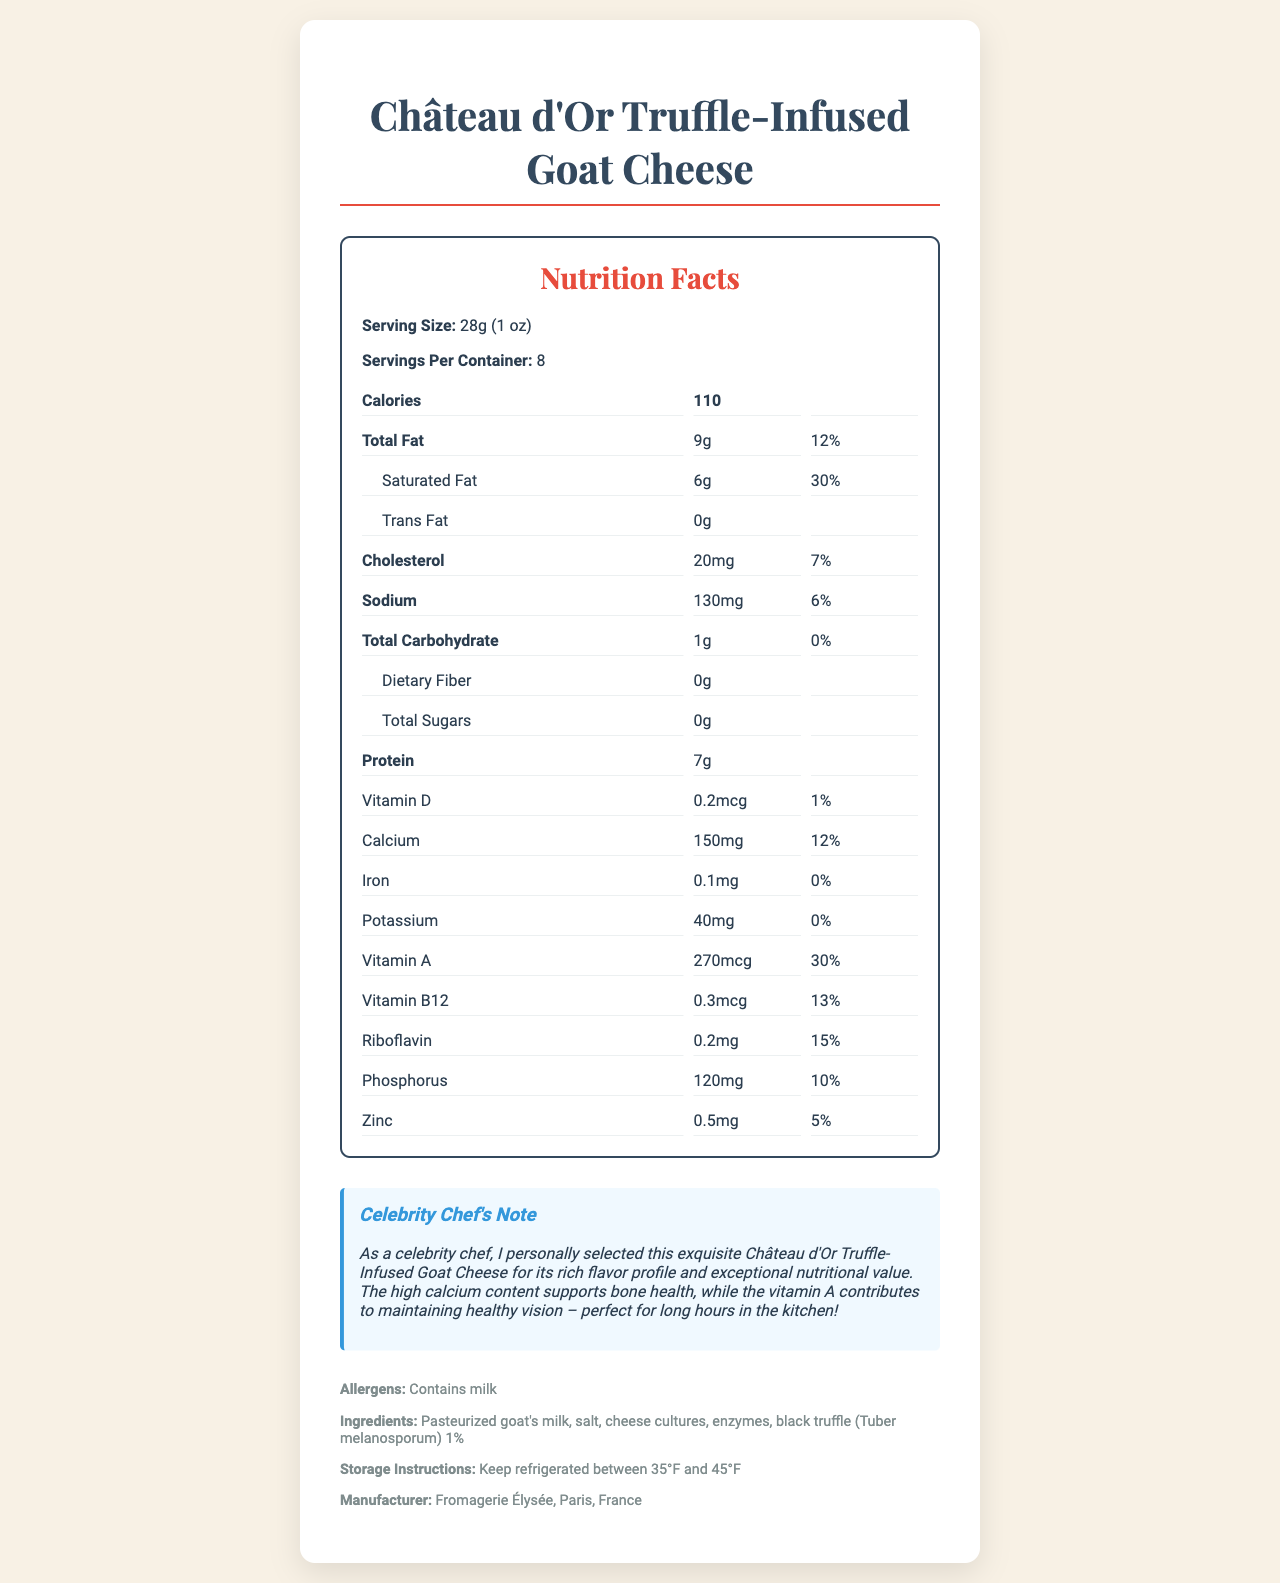how much calcium does one serving of Château d'Or Truffle-Infused Goat Cheese contain? The nutrition facts clearly state that each serving of 28g contains 150 mg of calcium.
Answer: 150 mg what percentage of the daily value for calcium does one serving provide? The document specifies that one serving provides 12% of the daily value for calcium.
Answer: 12% what vitamin has the highest daily value percentage in the cheese? The document lists Vitamin A with a daily value of 30%, which is the highest among the vitamins mentioned.
Answer: Vitamin A how much vitamin D is in one serving of the cheese? According to the nutrition facts, one serving contains 0.2 mcg of vitamin D.
Answer: 0.2 mcg how many grams of protein are in a serving? The document mentions that there are 7 grams of protein in each serving.
Answer: 7 g which vitamin contributes to healthy vision, according to the celebrity chef's note? The celebrity chef's note specifically mentions that vitamin A contributes to maintaining healthy vision.
Answer: Vitamin A how much phosphorus does the cheese contain per serving? The nutrition facts section lists phosphorus content as 120 mg per serving.
Answer: 120 mg what is the serving size of the Château d'Or Truffle-Infused Goat Cheese? The document defines the serving size as 28 grams, which is equivalent to 1 ounce.
Answer: 28g (1 oz) does the product contain any dietary fiber? The nutrition facts indicate that the cheese contains 0g of dietary fiber.
Answer: No what should be the storage temperature for this cheese? A. Below 35°F B. Between 35°F and 45°F C. Above 45°F The storage instructions clearly state that the cheese should be kept refrigerated between 35°F and 45°F.
Answer: B. Between 35°F and 45°F which of the following vitamins is not listed in the nutrition facts? A. Vitamin B6 B. Vitamin A C. Vitamin B12 The document does not mention Vitamin B6 in its nutrition facts section.
Answer: A. Vitamin B6 does this cheese contain trans fat? The nutrition facts state that the cheese contains 0g of trans fat.
Answer: No summarize the main idea of the document. The document outlines detailed nutritional information, allergen warnings, ingredients, storage instructions, manufacturer details, and includes a personal note from a celebrity chef emphasizing the cheese's benefits.
Answer: The document provides the nutrition facts for Château d'Or Truffle-Infused Goat Cheese, including its serving size, calorie content, and various nutritional values. It highlights the cheese’s rich flavor and high nutritional value, particularly its calcium and vitamin content, with a note from a celebrity chef on its benefits for bone health and vision. where is Fromagerie Élysée located? The manufacturer section of the document specifies that Fromagerie Élysée is located in Paris, France.
Answer: Paris, France how much total fat is there in one serving of the cheese? The nutrition facts show that one serving contains 9 grams of total fat.
Answer: 9g what percentage of the daily value for vitamin B12 does one serving provide? The document lists the daily value for vitamin B12 as 13% per serving.
Answer: 13% does the cheese contain any artificial additives? The document lists the ingredients but does not specify whether these are natural or artificial.
Answer: Cannot be determined 